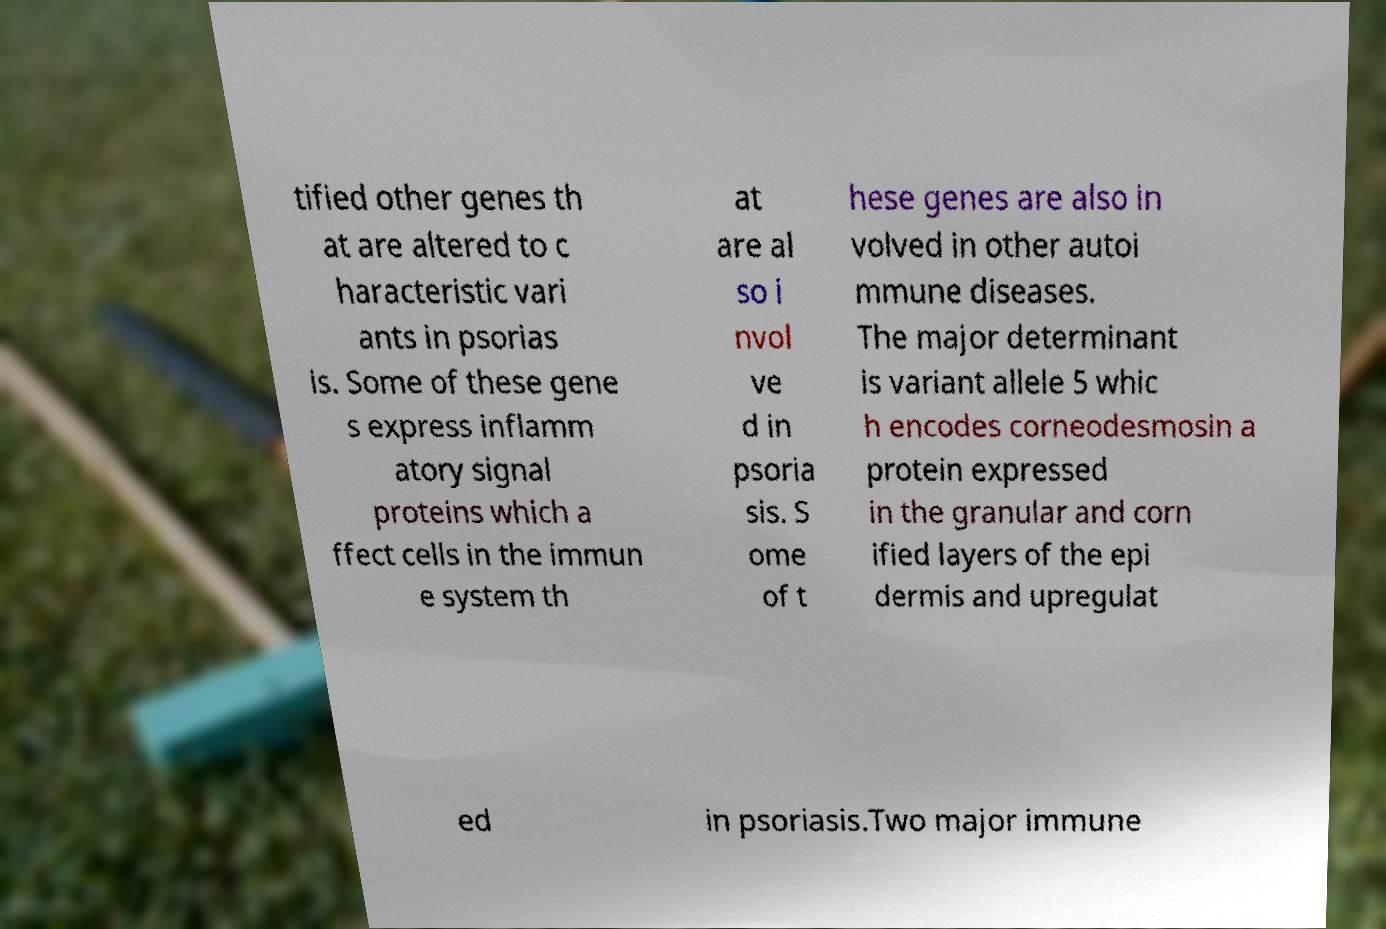Please read and relay the text visible in this image. What does it say? tified other genes th at are altered to c haracteristic vari ants in psorias is. Some of these gene s express inflamm atory signal proteins which a ffect cells in the immun e system th at are al so i nvol ve d in psoria sis. S ome of t hese genes are also in volved in other autoi mmune diseases. The major determinant is variant allele 5 whic h encodes corneodesmosin a protein expressed in the granular and corn ified layers of the epi dermis and upregulat ed in psoriasis.Two major immune 